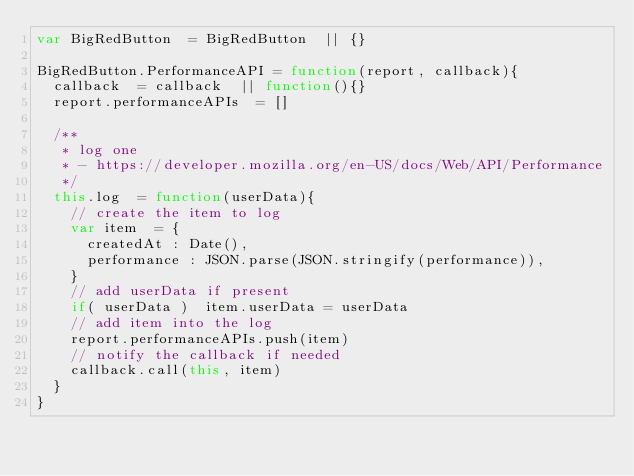<code> <loc_0><loc_0><loc_500><loc_500><_JavaScript_>var BigRedButton	= BigRedButton	|| {}

BigRedButton.PerformanceAPI	= function(report, callback){
	callback	= callback	|| function(){}
	report.performanceAPIs	= []
	
	/**
	 * log one
	 * - https://developer.mozilla.org/en-US/docs/Web/API/Performance
	 */
	this.log	= function(userData){
		// create the item to log
		var item	= {
			createdAt	: Date(),
			performance	: JSON.parse(JSON.stringify(performance)),
		}
		// add userData if present
		if( userData )	item.userData	= userData
		// add item into the log
		report.performanceAPIs.push(item)
		// notify the callback if needed
		callback.call(this, item)
	}
}

</code> 